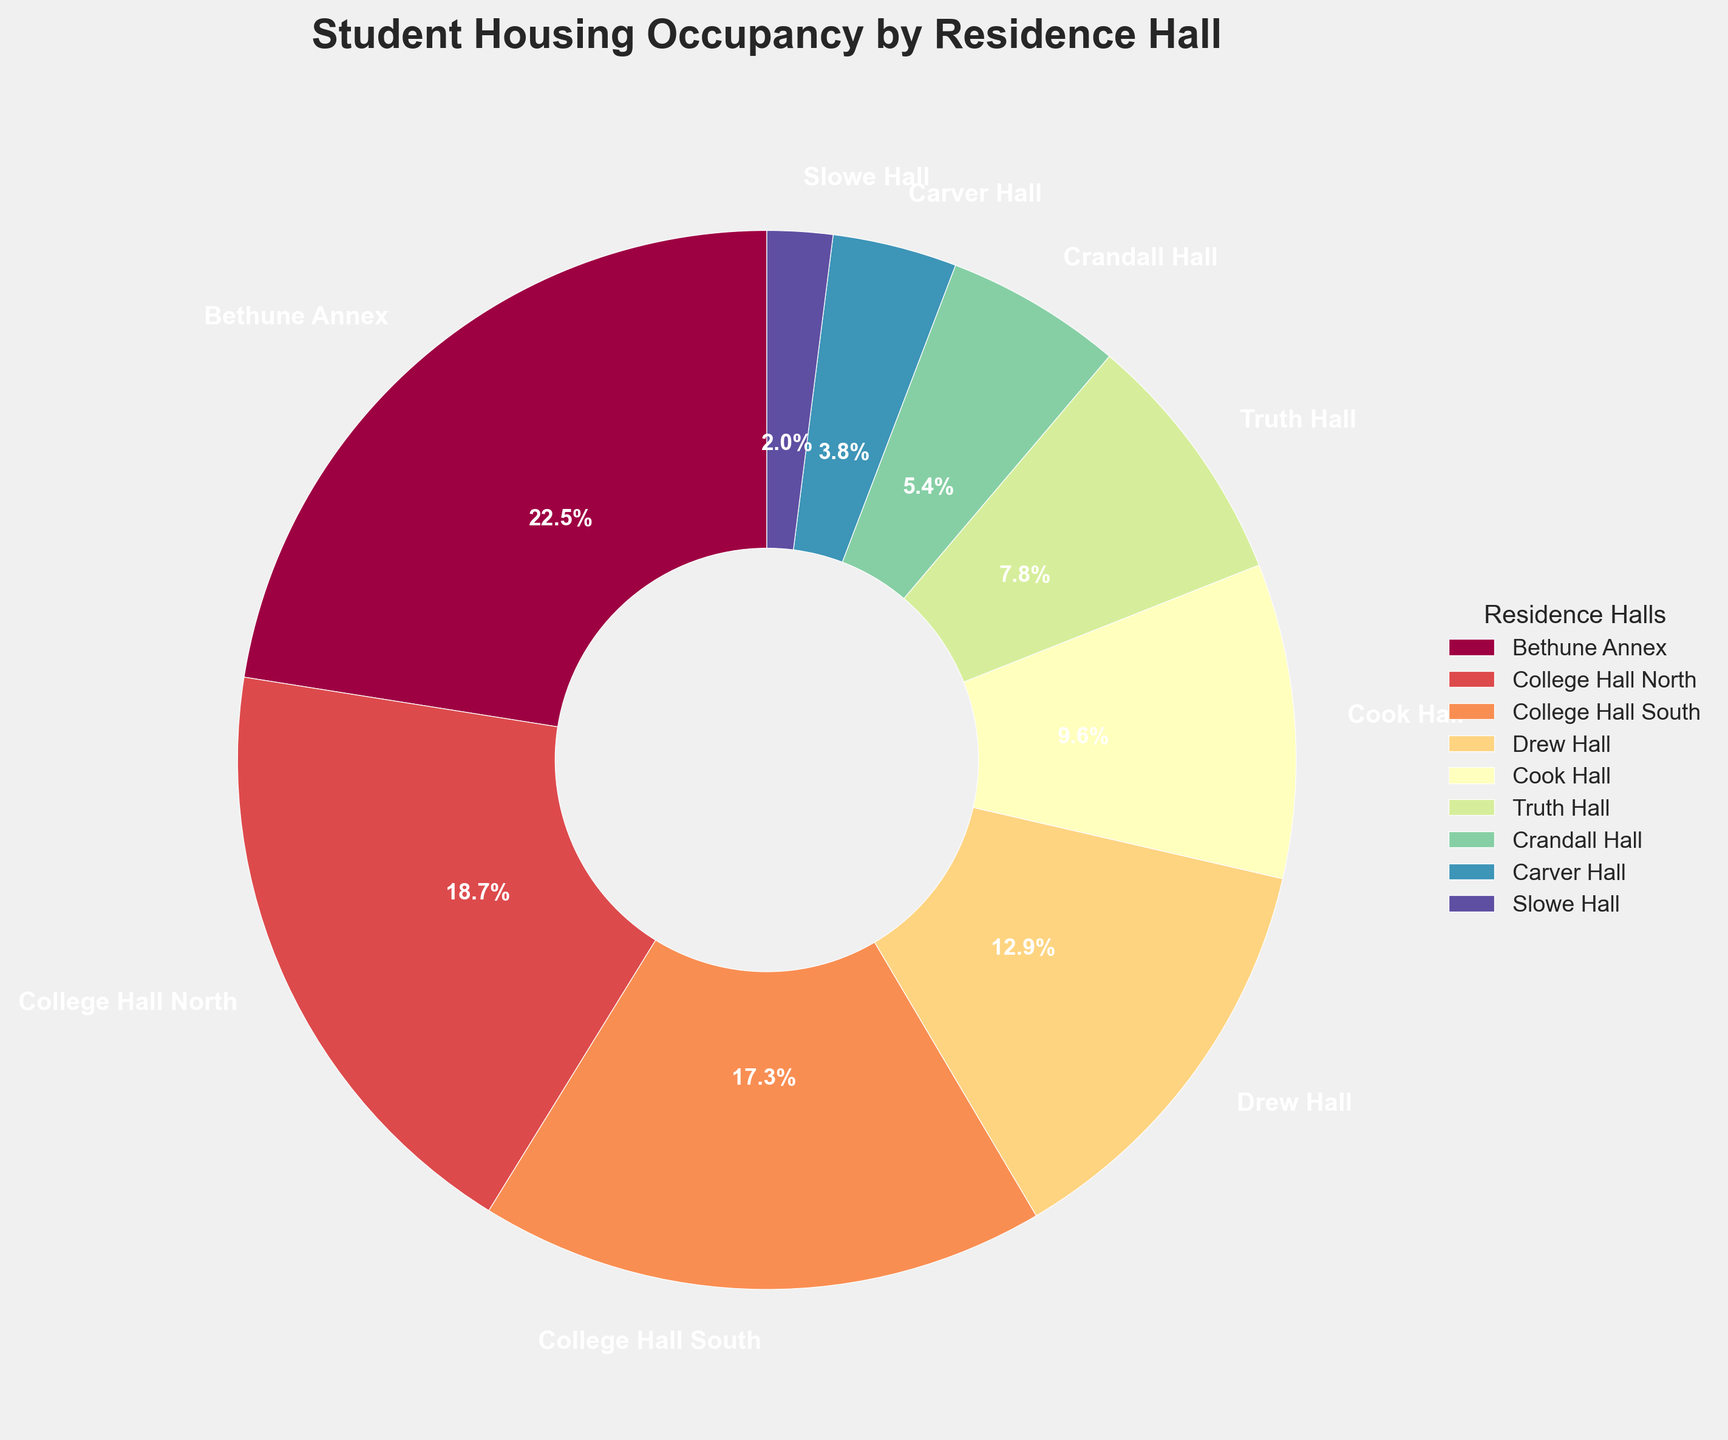What is the residence hall with the highest occupancy percentage? To find the residence hall with the highest occupancy percentage, look for the largest section of the pie chart. According to the chart, it is Bethune Annex.
Answer: Bethune Annex Which two residence halls have the lowest occupancy percentages? To identify the two residence halls with the lowest occupancy percentages, look for the smallest sections of the pie chart. These are Slowe Hall and Carver Hall.
Answer: Slowe Hall and Carver Hall What is the difference in occupancy percentage between College Hall North and College Hall South? College Hall North has an occupancy percentage of 18.7%, while College Hall South has 17.3%. The difference is found by subtracting 17.3 from 18.7.
Answer: 1.4% What is the combined occupancy percentage of Drew Hall, Cook Hall, and Crandall Hall? Add the occupancy percentages of Drew Hall (12.9%), Cook Hall (9.6%), and Crandall Hall (5.4%). The sum is 12.9 + 9.6 + 5.4.
Answer: 27.9% Does Truth Hall have a greater occupancy percentage than Crandall Hall? Compare the pie sections for Truth Hall and Crandall Hall. Truth Hall has an occupancy percentage of 7.8%, while Crandall Hall has 5.4%. As 7.8 is greater than 5.4, Truth Hall has a greater occupancy.
Answer: Yes What is the visual representation difference between the segments for College Hall North and Carver Hall in the pie chart? Look at the size (area) of the pie segments. College Hall North occupies a significantly larger segment of the pie chart (18.7%) compared to Carver Hall (3.8%).
Answer: College Hall North's segment is much larger If you combine the occupancy of Carver Hall and Slowe Hall, is it greater than the occupancy of Drew Hall? Carver Hall has an occupancy of 3.8% and Slowe Hall has 2.0%. Their combined total is 3.8 + 2.0 = 5.8%. Drew Hall has 12.9%, which is greater than 5.8%.
Answer: No Is the total occupancy percentage of College Hall North and South greater than the occupancy percentage of Bethune Annex? College Hall North has 18.7% and South has 17.3%. Their combined total is 18.7 + 17.3 = 36.0%. Bethune Annex has 22.5%, which is less than 36.0%.
Answer: Yes How does the percentage of the largest segment compare to the combined percentage of the smallest three segments? The largest segment is Bethune Annex at 22.5%. The smallest three segments combined (Slowe Hall 2.0%, Carver Hall 3.8%, and Crandall Hall 5.4%) sum up to 2.0 + 3.8 + 5.4 = 11.2%. 22.5% is greater than 11.2%.
Answer: 22.5% is greater 